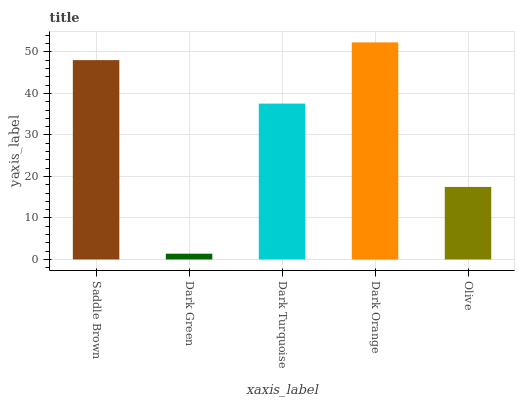Is Dark Turquoise the minimum?
Answer yes or no. No. Is Dark Turquoise the maximum?
Answer yes or no. No. Is Dark Turquoise greater than Dark Green?
Answer yes or no. Yes. Is Dark Green less than Dark Turquoise?
Answer yes or no. Yes. Is Dark Green greater than Dark Turquoise?
Answer yes or no. No. Is Dark Turquoise less than Dark Green?
Answer yes or no. No. Is Dark Turquoise the high median?
Answer yes or no. Yes. Is Dark Turquoise the low median?
Answer yes or no. Yes. Is Saddle Brown the high median?
Answer yes or no. No. Is Dark Orange the low median?
Answer yes or no. No. 